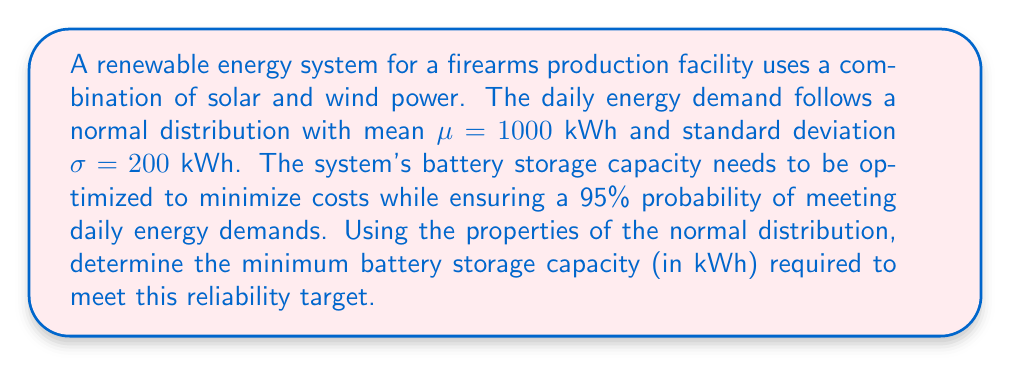Could you help me with this problem? To solve this problem, we'll follow these steps:

1) For a normal distribution, 95% of the values fall within 1.96 standard deviations of the mean.

2) The required capacity can be calculated as:
   $$\text{Capacity} = \mu + 1.96\sigma$$

3) Substituting the given values:
   $$\text{Capacity} = 1000 + 1.96 * 200$$

4) Calculate:
   $$\text{Capacity} = 1000 + 392 = 1392\text{ kWh}$$

This capacity ensures that the battery storage can meet the daily energy demand with a 95% probability, optimizing the system for the firearms production facility's needs while minimizing unnecessary capacity and associated costs.
Answer: 1392 kWh 